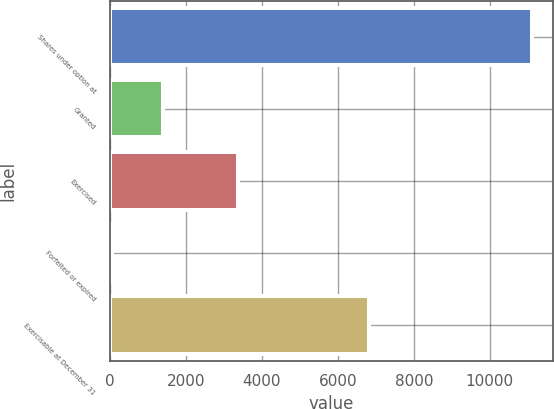Convert chart. <chart><loc_0><loc_0><loc_500><loc_500><bar_chart><fcel>Shares under option at<fcel>Granted<fcel>Exercised<fcel>Forfeited or expired<fcel>Exercisable at December 31<nl><fcel>11113<fcel>1391.6<fcel>3376<fcel>68<fcel>6835<nl></chart> 